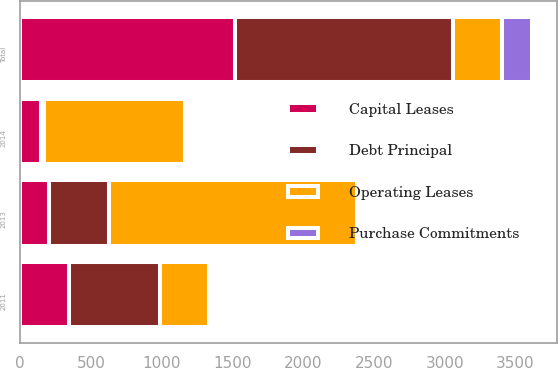Convert chart. <chart><loc_0><loc_0><loc_500><loc_500><stacked_bar_chart><ecel><fcel>2011<fcel>2013<fcel>2014<fcel>Total<nl><fcel>Purchase Commitments<fcel>18<fcel>19<fcel>20<fcel>209<nl><fcel>Capital Leases<fcel>348<fcel>205<fcel>150<fcel>1515<nl><fcel>Operating Leases<fcel>345<fcel>1750<fcel>1000<fcel>345<nl><fcel>Debt Principal<fcel>642<fcel>425<fcel>16<fcel>1546<nl></chart> 